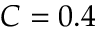<formula> <loc_0><loc_0><loc_500><loc_500>C = 0 . 4</formula> 